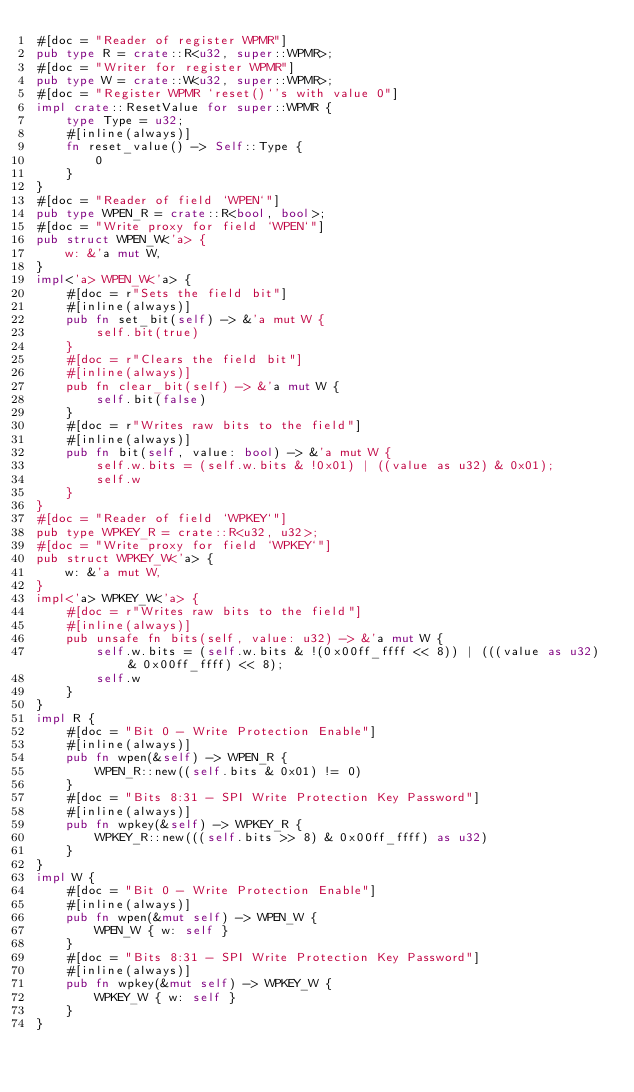<code> <loc_0><loc_0><loc_500><loc_500><_Rust_>#[doc = "Reader of register WPMR"]
pub type R = crate::R<u32, super::WPMR>;
#[doc = "Writer for register WPMR"]
pub type W = crate::W<u32, super::WPMR>;
#[doc = "Register WPMR `reset()`'s with value 0"]
impl crate::ResetValue for super::WPMR {
    type Type = u32;
    #[inline(always)]
    fn reset_value() -> Self::Type {
        0
    }
}
#[doc = "Reader of field `WPEN`"]
pub type WPEN_R = crate::R<bool, bool>;
#[doc = "Write proxy for field `WPEN`"]
pub struct WPEN_W<'a> {
    w: &'a mut W,
}
impl<'a> WPEN_W<'a> {
    #[doc = r"Sets the field bit"]
    #[inline(always)]
    pub fn set_bit(self) -> &'a mut W {
        self.bit(true)
    }
    #[doc = r"Clears the field bit"]
    #[inline(always)]
    pub fn clear_bit(self) -> &'a mut W {
        self.bit(false)
    }
    #[doc = r"Writes raw bits to the field"]
    #[inline(always)]
    pub fn bit(self, value: bool) -> &'a mut W {
        self.w.bits = (self.w.bits & !0x01) | ((value as u32) & 0x01);
        self.w
    }
}
#[doc = "Reader of field `WPKEY`"]
pub type WPKEY_R = crate::R<u32, u32>;
#[doc = "Write proxy for field `WPKEY`"]
pub struct WPKEY_W<'a> {
    w: &'a mut W,
}
impl<'a> WPKEY_W<'a> {
    #[doc = r"Writes raw bits to the field"]
    #[inline(always)]
    pub unsafe fn bits(self, value: u32) -> &'a mut W {
        self.w.bits = (self.w.bits & !(0x00ff_ffff << 8)) | (((value as u32) & 0x00ff_ffff) << 8);
        self.w
    }
}
impl R {
    #[doc = "Bit 0 - Write Protection Enable"]
    #[inline(always)]
    pub fn wpen(&self) -> WPEN_R {
        WPEN_R::new((self.bits & 0x01) != 0)
    }
    #[doc = "Bits 8:31 - SPI Write Protection Key Password"]
    #[inline(always)]
    pub fn wpkey(&self) -> WPKEY_R {
        WPKEY_R::new(((self.bits >> 8) & 0x00ff_ffff) as u32)
    }
}
impl W {
    #[doc = "Bit 0 - Write Protection Enable"]
    #[inline(always)]
    pub fn wpen(&mut self) -> WPEN_W {
        WPEN_W { w: self }
    }
    #[doc = "Bits 8:31 - SPI Write Protection Key Password"]
    #[inline(always)]
    pub fn wpkey(&mut self) -> WPKEY_W {
        WPKEY_W { w: self }
    }
}
</code> 